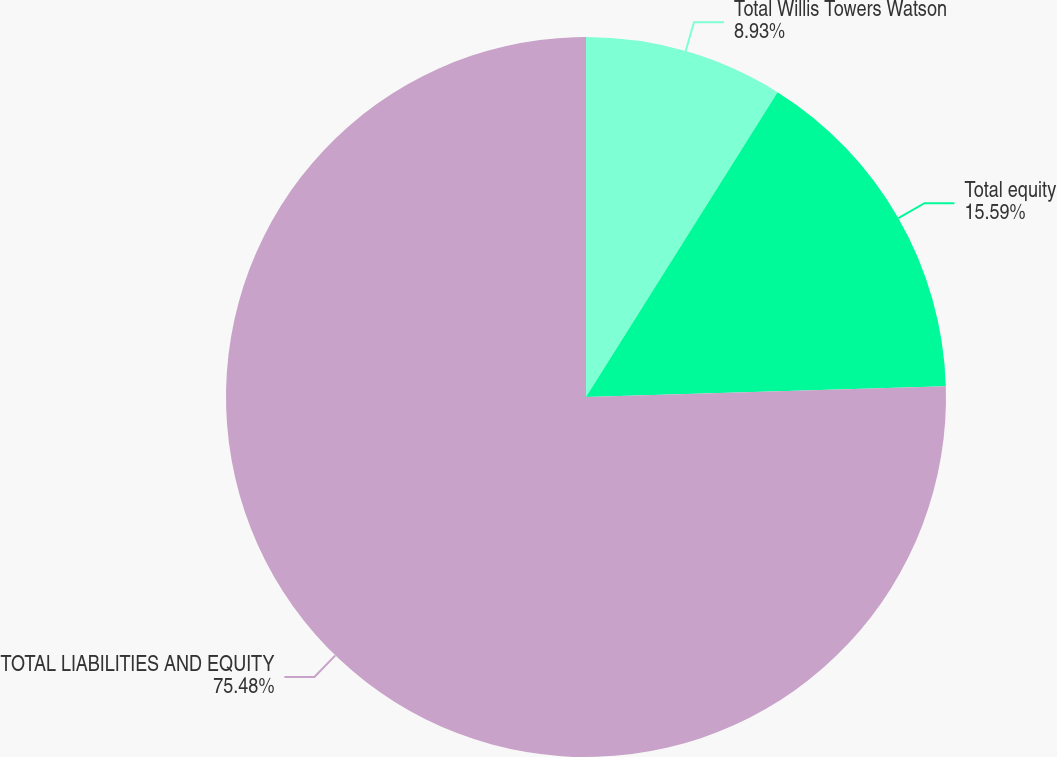Convert chart to OTSL. <chart><loc_0><loc_0><loc_500><loc_500><pie_chart><fcel>Total Willis Towers Watson<fcel>Total equity<fcel>TOTAL LIABILITIES AND EQUITY<nl><fcel>8.93%<fcel>15.59%<fcel>75.48%<nl></chart> 